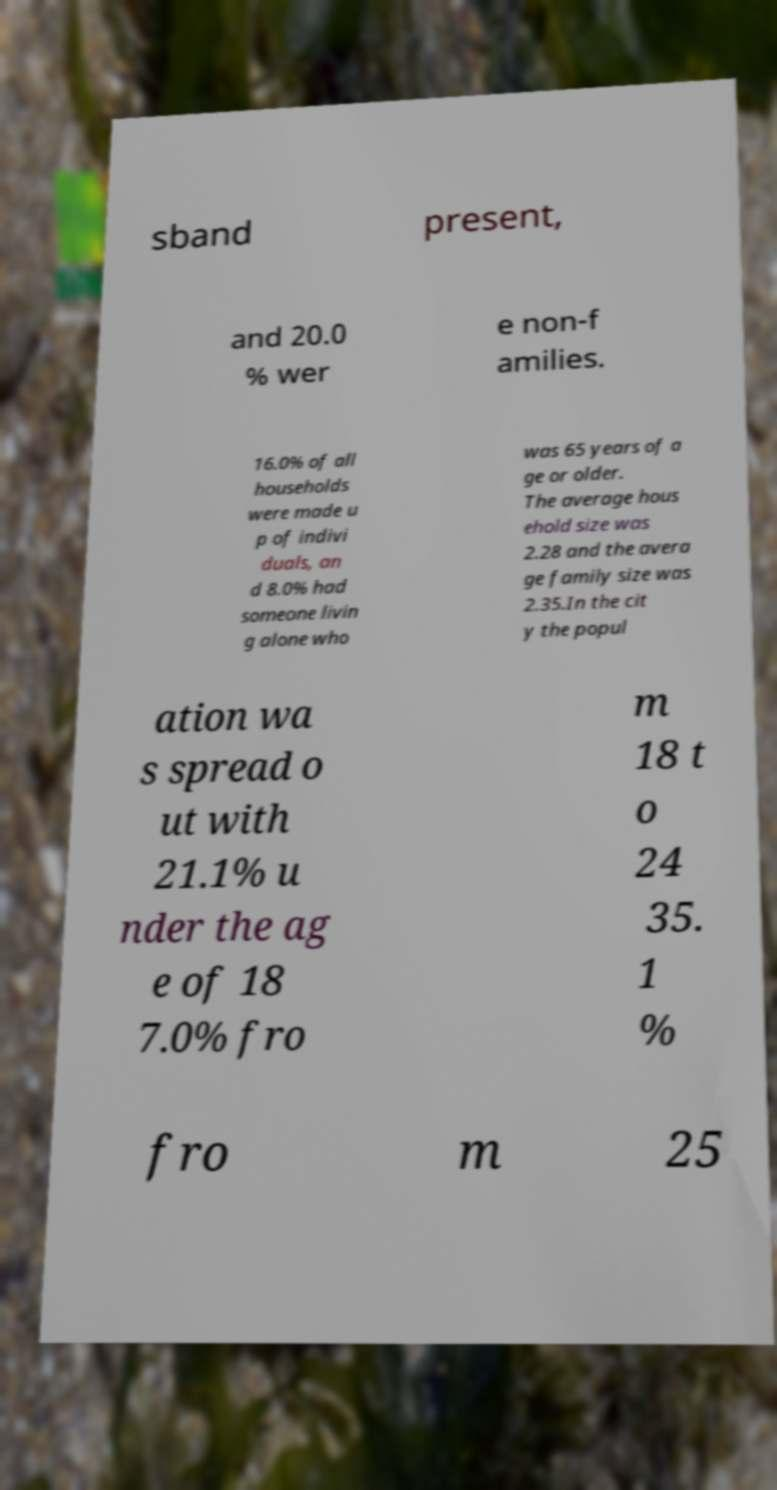Can you accurately transcribe the text from the provided image for me? sband present, and 20.0 % wer e non-f amilies. 16.0% of all households were made u p of indivi duals, an d 8.0% had someone livin g alone who was 65 years of a ge or older. The average hous ehold size was 2.28 and the avera ge family size was 2.35.In the cit y the popul ation wa s spread o ut with 21.1% u nder the ag e of 18 7.0% fro m 18 t o 24 35. 1 % fro m 25 